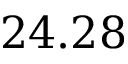<formula> <loc_0><loc_0><loc_500><loc_500>2 4 . 2 8</formula> 